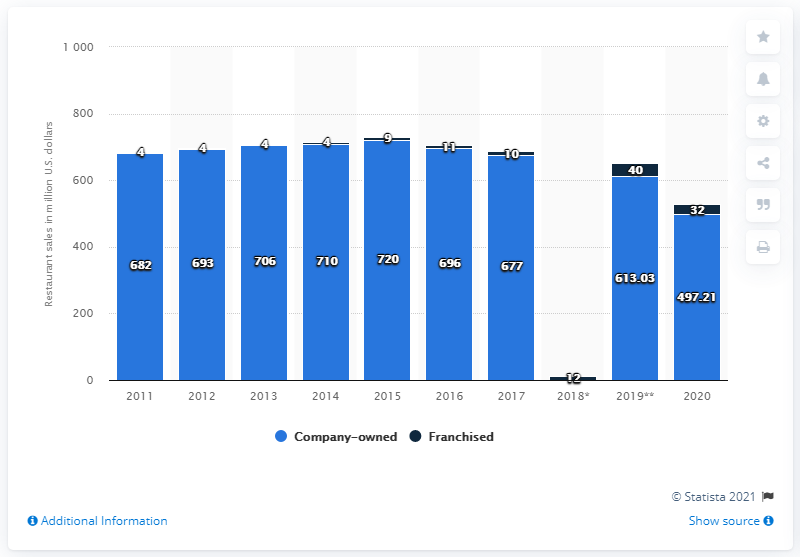Draw attention to some important aspects in this diagram. In 2020, the sales of Carrabba's Italian Grill restaurants in the United States were $497.21 million. In 2020, Carrabba's Italian Grill had franchised restaurant sales of 32. 